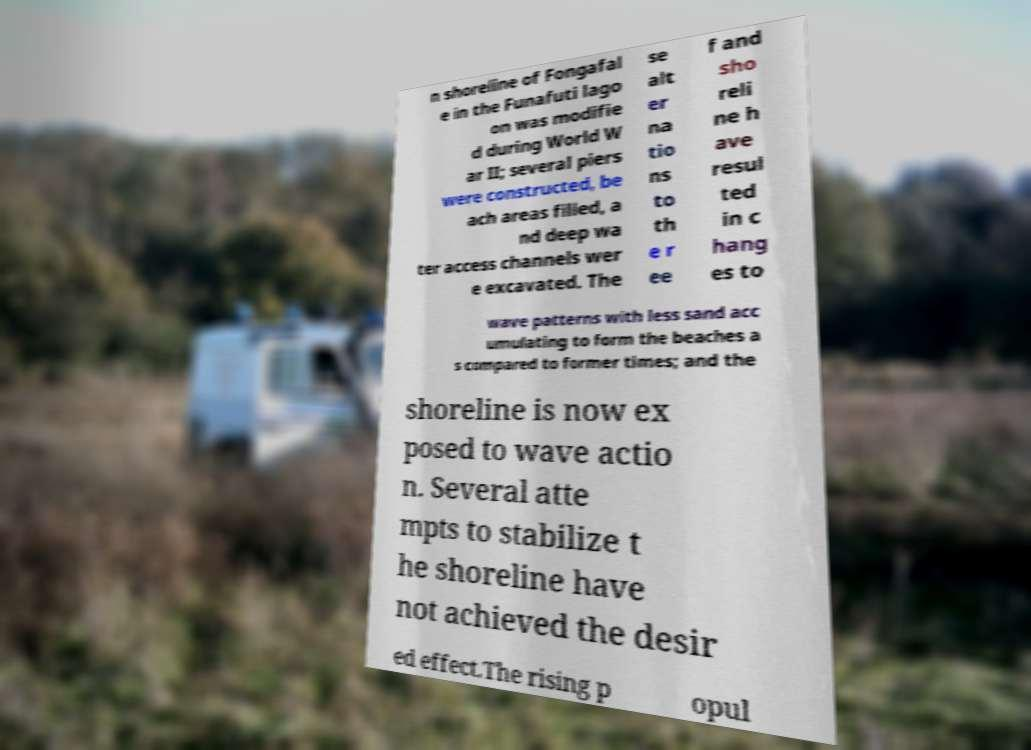Can you read and provide the text displayed in the image?This photo seems to have some interesting text. Can you extract and type it out for me? n shoreline of Fongafal e in the Funafuti lago on was modifie d during World W ar II; several piers were constructed, be ach areas filled, a nd deep wa ter access channels wer e excavated. The se alt er na tio ns to th e r ee f and sho reli ne h ave resul ted in c hang es to wave patterns with less sand acc umulating to form the beaches a s compared to former times; and the shoreline is now ex posed to wave actio n. Several atte mpts to stabilize t he shoreline have not achieved the desir ed effect.The rising p opul 